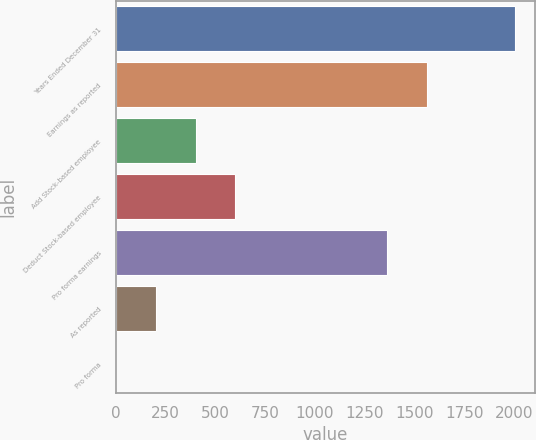<chart> <loc_0><loc_0><loc_500><loc_500><bar_chart><fcel>Years Ended December 31<fcel>Earnings as reported<fcel>Add Stock-based employee<fcel>Deduct Stock-based employee<fcel>Pro forma earnings<fcel>As reported<fcel>Pro forma<nl><fcel>2004<fcel>1563.34<fcel>401.26<fcel>601.6<fcel>1363<fcel>200.92<fcel>0.58<nl></chart> 